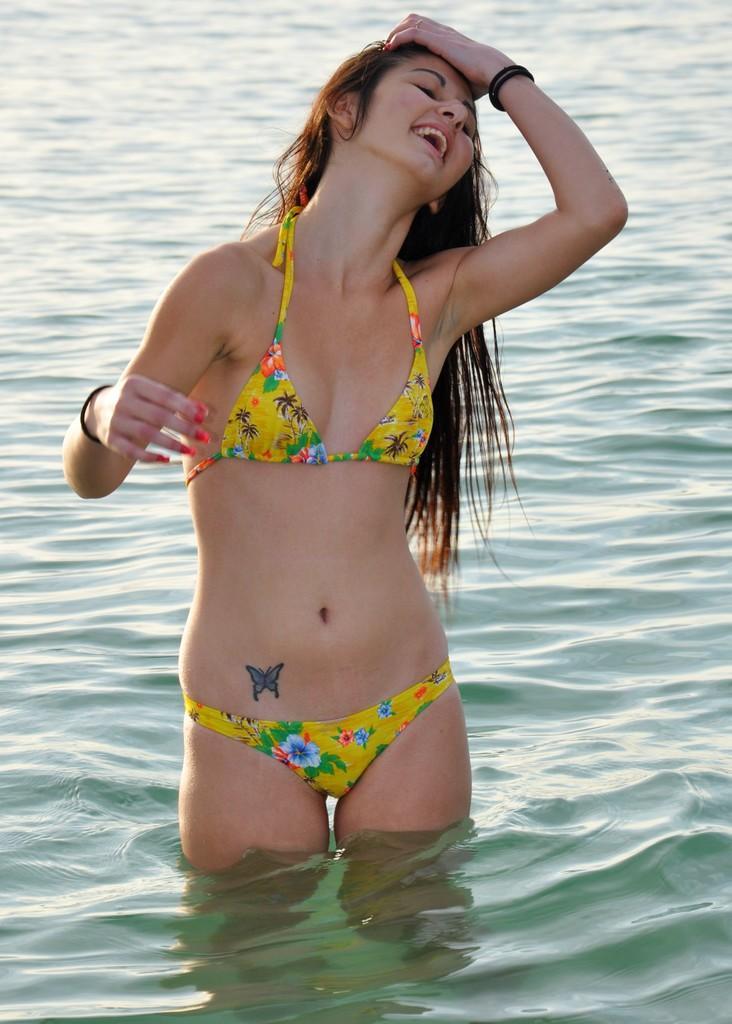Please provide a concise description of this image. In the picture I can see a woman wearing a bikini and standing in the water. 